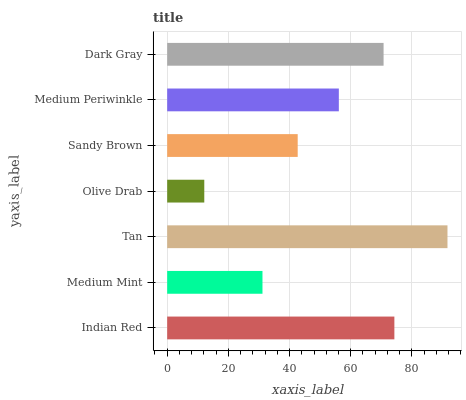Is Olive Drab the minimum?
Answer yes or no. Yes. Is Tan the maximum?
Answer yes or no. Yes. Is Medium Mint the minimum?
Answer yes or no. No. Is Medium Mint the maximum?
Answer yes or no. No. Is Indian Red greater than Medium Mint?
Answer yes or no. Yes. Is Medium Mint less than Indian Red?
Answer yes or no. Yes. Is Medium Mint greater than Indian Red?
Answer yes or no. No. Is Indian Red less than Medium Mint?
Answer yes or no. No. Is Medium Periwinkle the high median?
Answer yes or no. Yes. Is Medium Periwinkle the low median?
Answer yes or no. Yes. Is Medium Mint the high median?
Answer yes or no. No. Is Sandy Brown the low median?
Answer yes or no. No. 